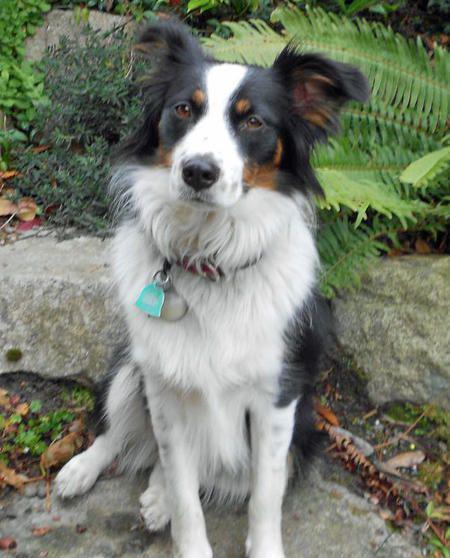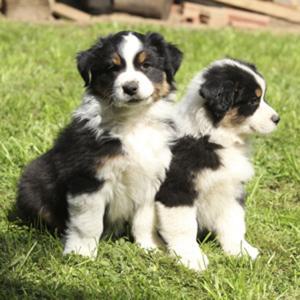The first image is the image on the left, the second image is the image on the right. Examine the images to the left and right. Is the description "There are exactly two dogs in the image on the right." accurate? Answer yes or no. Yes. 